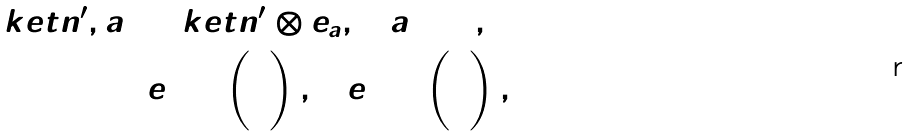<formula> <loc_0><loc_0><loc_500><loc_500>\ k e t { n ^ { \prime } , a } = \ k e t { n ^ { \prime } } \otimes e _ { a } , \quad a = 0 , 1 \\ e _ { 0 } = \begin{pmatrix} 1 \\ 0 \end{pmatrix} , \quad e _ { 1 } = \begin{pmatrix} 0 \\ 1 \end{pmatrix} ,</formula> 